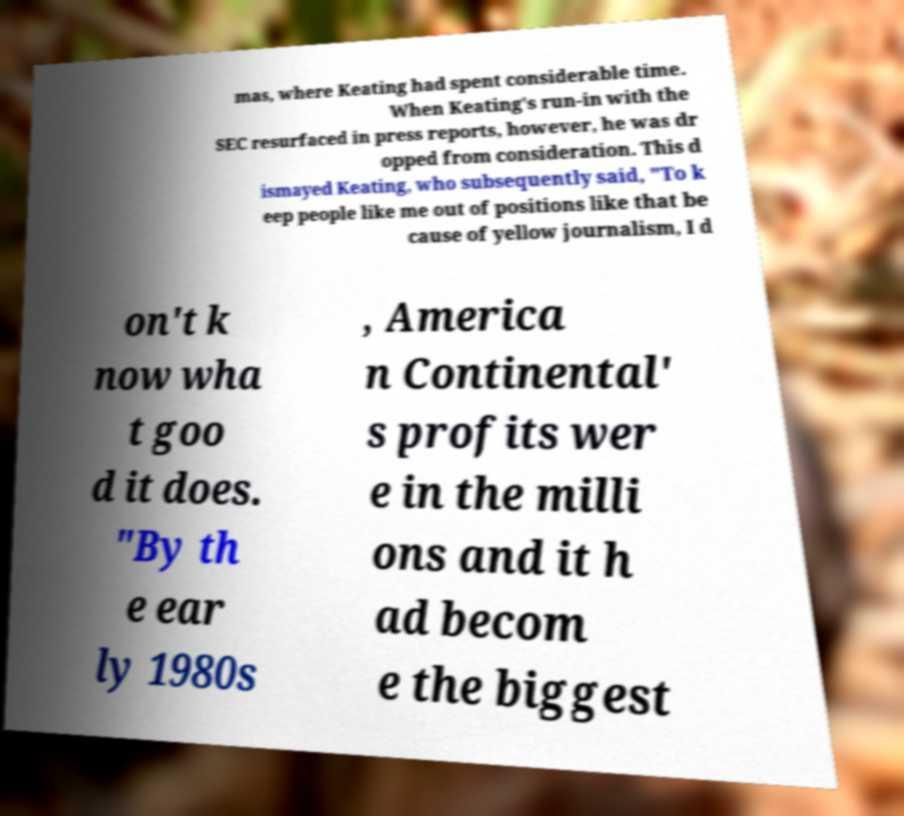For documentation purposes, I need the text within this image transcribed. Could you provide that? mas, where Keating had spent considerable time. When Keating's run-in with the SEC resurfaced in press reports, however, he was dr opped from consideration. This d ismayed Keating, who subsequently said, "To k eep people like me out of positions like that be cause of yellow journalism, I d on't k now wha t goo d it does. "By th e ear ly 1980s , America n Continental' s profits wer e in the milli ons and it h ad becom e the biggest 